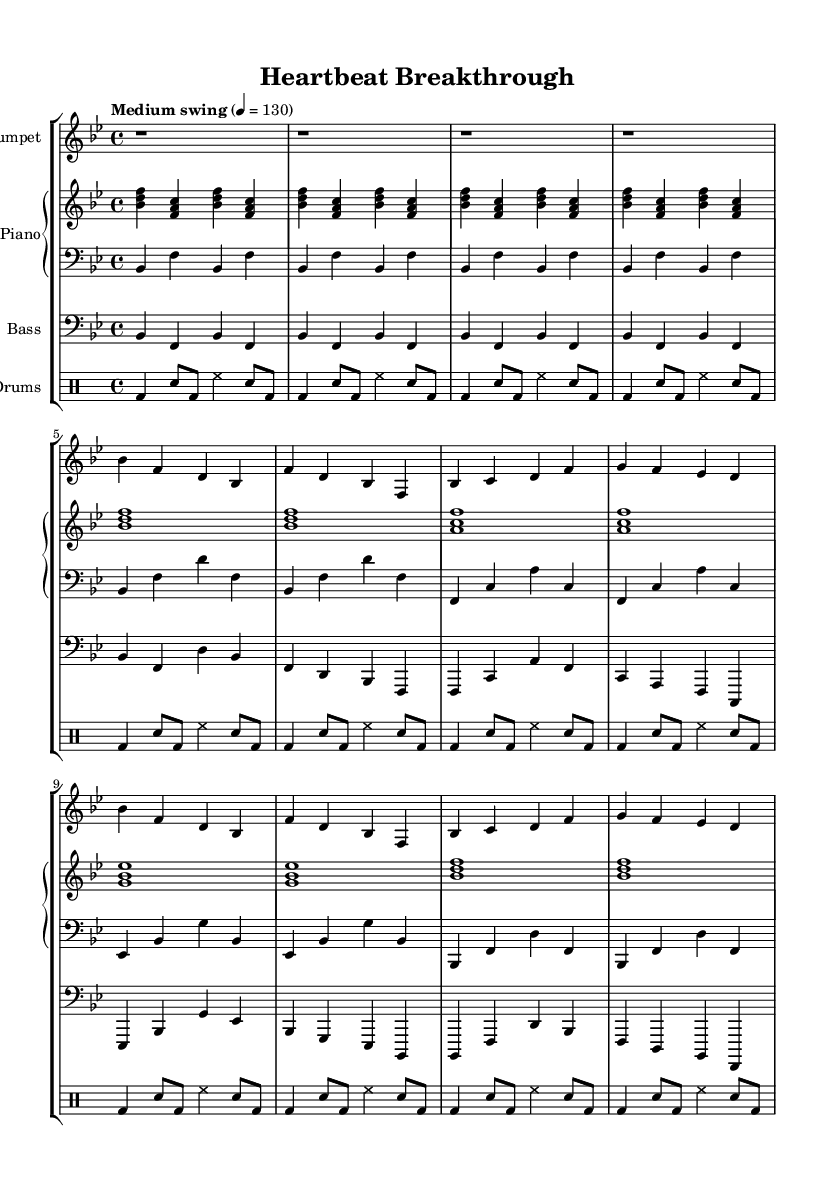What is the key signature of this music? The key signature is B flat major, which has two flats (B flat and E flat). This can be determined from the presence of the flat signs at the beginning of the staff.
Answer: B flat major What is the time signature of this music? The time signature is 4/4, indicated at the beginning of the score where the numbers are located. This means there are four beats per measure and the quarter note gets one beat.
Answer: 4/4 What is the tempo marking for this piece? The tempo marking is "Medium swing," which provides a rhythmic feel typical of swing jazz. It's noted above the staff with a metronome marking of 130 BPM.
Answer: Medium swing How many bars are in the A section of the music? The A section consists of 8 bars, which can be counted from the music notation indicating the first section's measures. The layout of the notes indicates these first 8 bars distinctly.
Answer: 8 bars What instruments are featured in this piece? The instruments featured are Trumpet, Piano, Bass, and Drums, as labeled at the beginning of each respective staff in the score layout.
Answer: Trumpet, Piano, Bass, Drums What is the main rhythmic feel characteristic of this jazz piece? The main rhythmic feel is a swing, which is common in jazz music and suggested by the tempo marking and the notation style of the rhythms throughout the piece.
Answer: Swing 